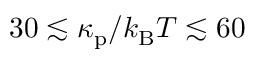Convert formula to latex. <formula><loc_0><loc_0><loc_500><loc_500>3 0 \lesssim \kappa _ { p } / k _ { B } T \lesssim 6 0</formula> 